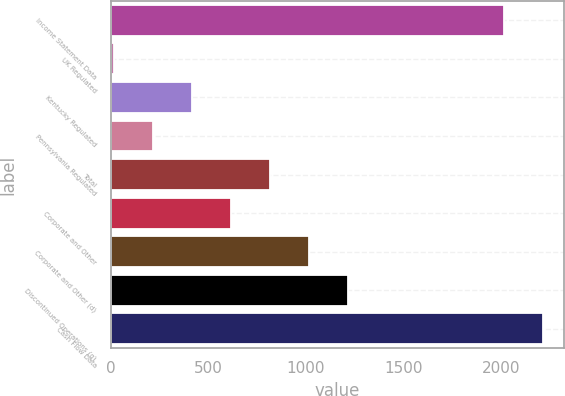Convert chart to OTSL. <chart><loc_0><loc_0><loc_500><loc_500><bar_chart><fcel>Income Statement Data<fcel>UK Regulated<fcel>Kentucky Regulated<fcel>Pennsylvania Regulated<fcel>Total<fcel>Corporate and Other<fcel>Corporate and Other (d)<fcel>Discontinued Operations (g)<fcel>Cash Flow Data<nl><fcel>2013<fcel>19<fcel>417.8<fcel>218.4<fcel>816.6<fcel>617.2<fcel>1016<fcel>1215.4<fcel>2212.4<nl></chart> 